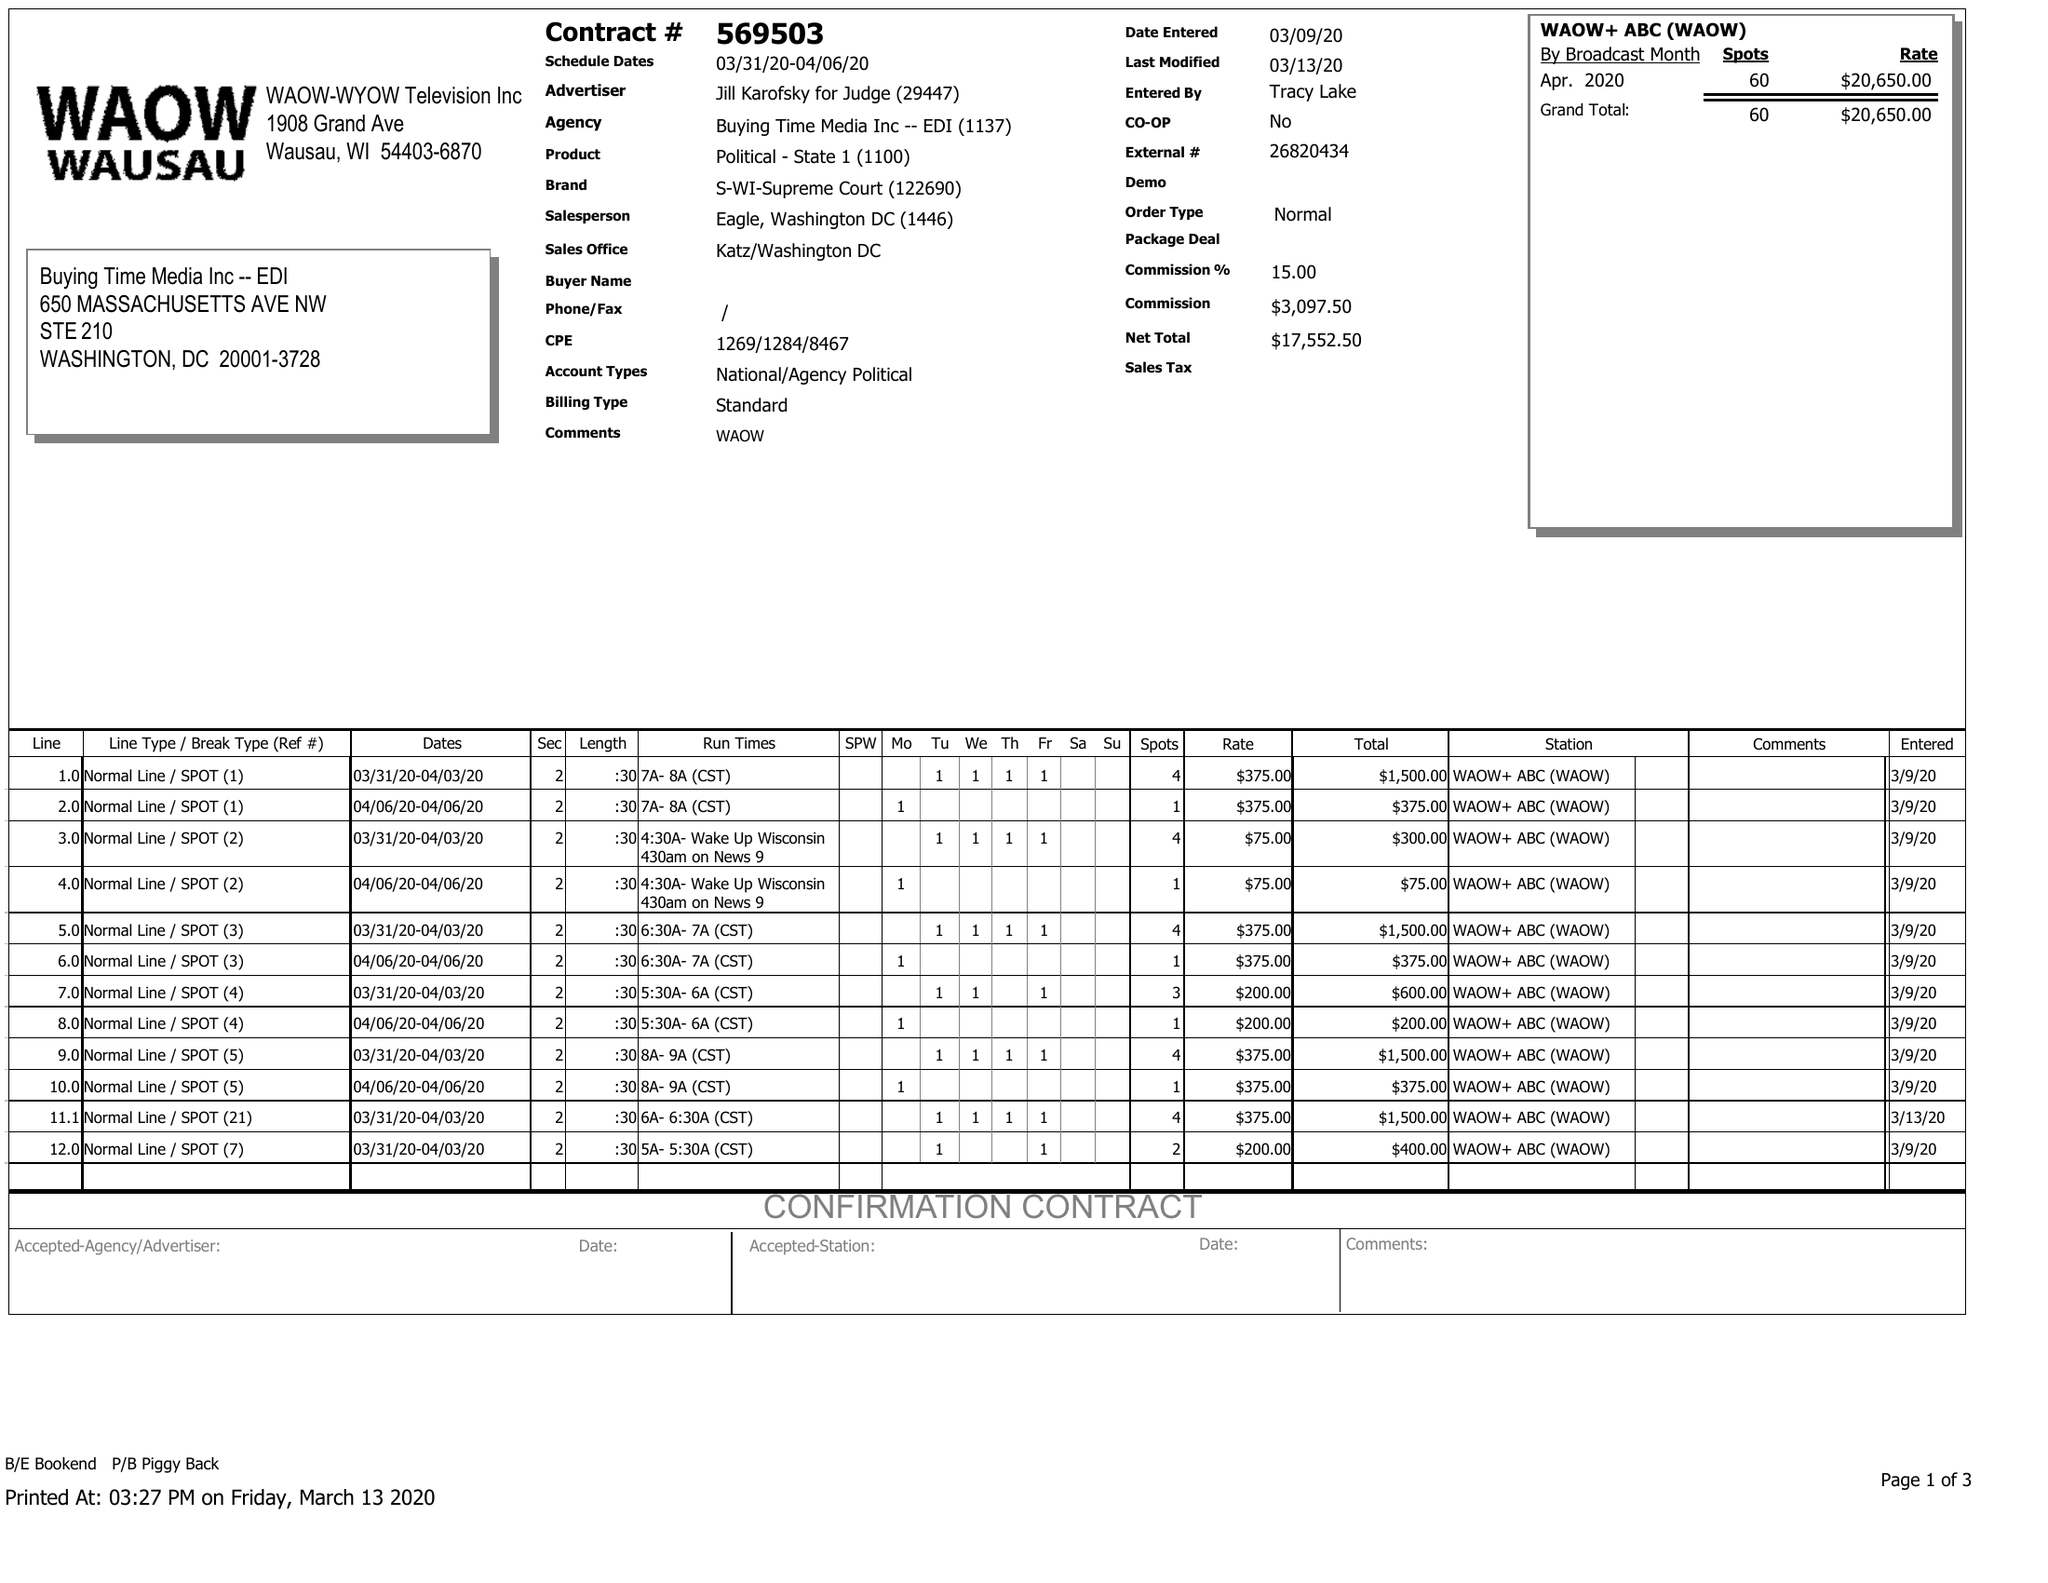What is the value for the contract_num?
Answer the question using a single word or phrase. 569503 